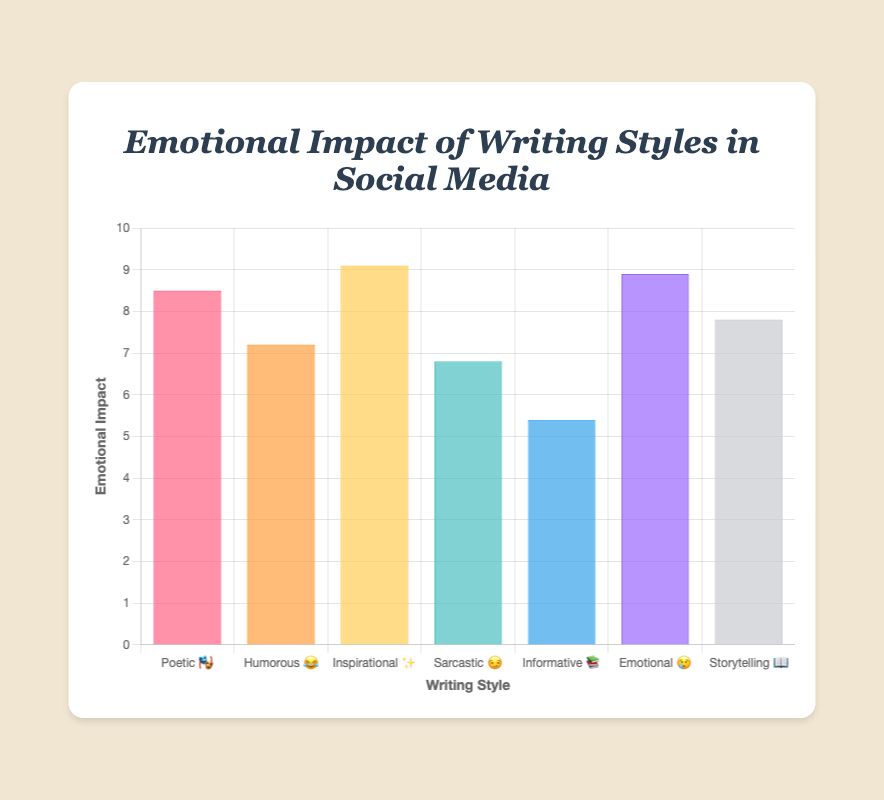What's the title of the figure? The title is displayed at the top of the figure above the chart. It reads, "Emotional Impact of Writing Styles in Social Media".
Answer: Emotional Impact of Writing Styles in Social Media Which writing style has the highest emotional impact? By looking at the height of the bars, the 'Inspirational' style (✨) has the highest emotional impact value.
Answer: Inspirational ✨ How many writing styles are illustrated in the figure? The x-axis lists all the different writing styles with their corresponding emoji. There are seven writing styles presented.
Answer: 7 Which writing style has the lowest emotional impact and what is its value? The 'Informative' style (📚) has the lowest bar height, indicating the lowest emotional impact. The value is 5.4.
Answer: Informative 📚, 5.4 Compare the emotional impact of 'Sarcastic' and 'Storytelling' styles. Which one is higher? The bar for 'Storytelling' (📖) is higher than the bar for 'Sarcastic' (😏). Thus, 'Storytelling' has a higher emotional impact.
Answer: Storytelling 📖 What is the emotional impact difference between 'Poetic' and 'Humorous' styles? The emotional impact for 'Poetic' (🎭) is 8.5 and for 'Humorous' (😂) is 7.2. The difference is 8.5 - 7.2 = 1.3.
Answer: 1.3 List the writing styles that have an emotional impact greater than 8.0. By observing the bar heights, 'Poetic' (🎭), 'Inspirational' (✨), and 'Emotional' (😢) have impacts greater than 8.0.
Answer: Poetic 🎭, Inspirational ✨, Emotional 😢 What's the average emotional impact of all the styles combined? Add all the impact values: 8.5 + 7.2 + 9.1 + 6.8 + 5.4 + 8.9 + 7.8 = 53.7. Divide by the number of styles: 53.7 / 7 = 7.67.
Answer: 7.67 Which colors represent the 'Humorous' and 'Emotional' styles? The bars for 'Humorous' (😂) and 'Emotional' (😢) are represented by shades resembling orange and purple, respectively.
Answer: Orange, Purple 